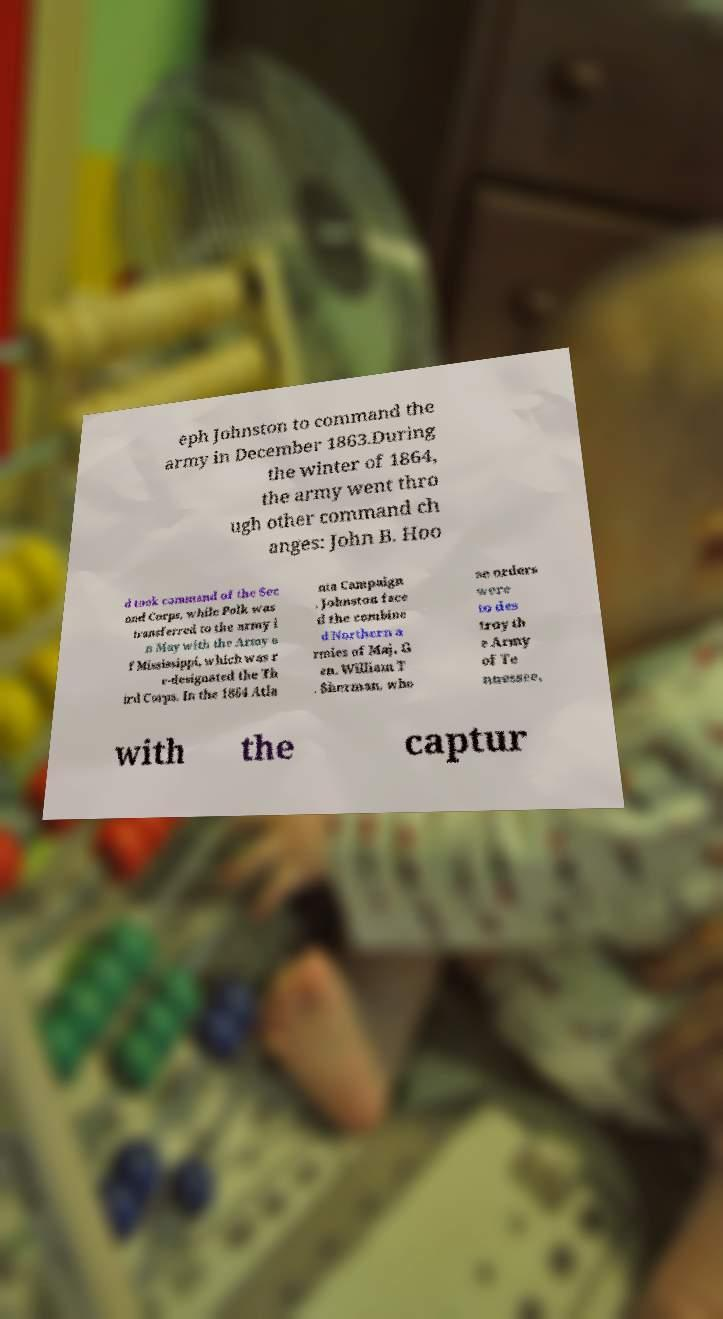Could you assist in decoding the text presented in this image and type it out clearly? eph Johnston to command the army in December 1863.During the winter of 1864, the army went thro ugh other command ch anges: John B. Hoo d took command of the Sec ond Corps, while Polk was transferred to the army i n May with the Army o f Mississippi, which was r e-designated the Th ird Corps. In the 1864 Atla nta Campaign , Johnston face d the combine d Northern a rmies of Maj. G en. William T . Sherman, who se orders were to des troy th e Army of Te nnessee, with the captur 